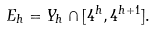<formula> <loc_0><loc_0><loc_500><loc_500>E _ { h } = Y _ { h } \cap [ 4 ^ { h } , 4 ^ { h + 1 } ] .</formula> 